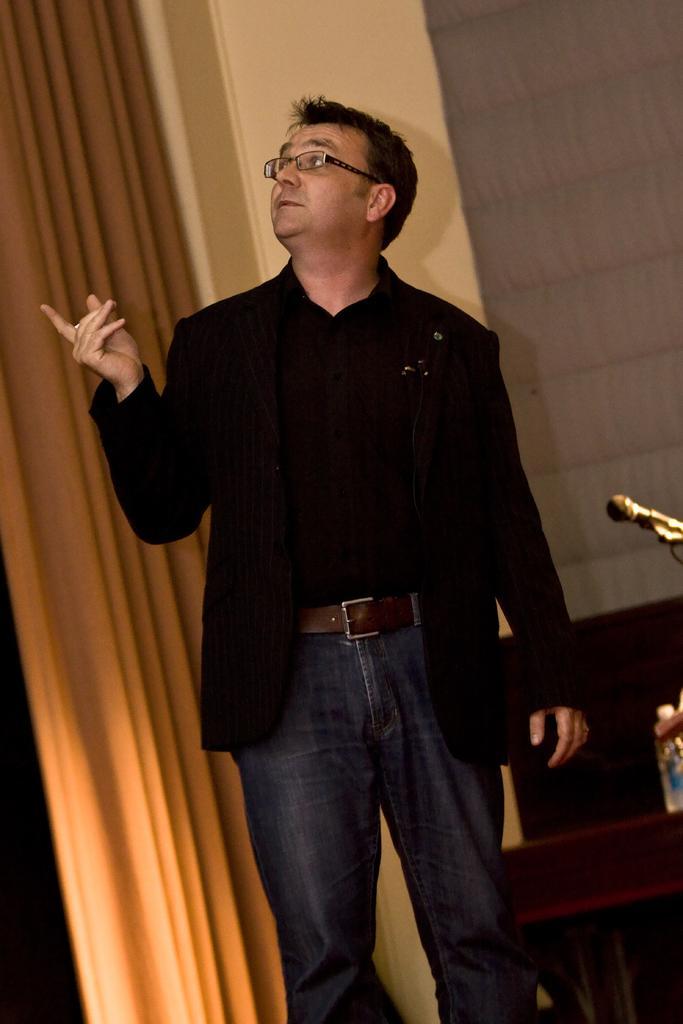Describe this image in one or two sentences. In this image I can see one man is standing in the front. I can see he is wearing black shirt, black blazer, brown belt, jeans and specs. On the right of this image I can see a mic, a bottle and on the left side I can see a curtain. 